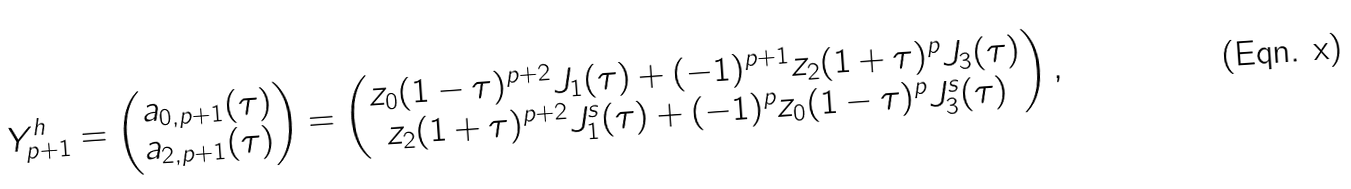Convert formula to latex. <formula><loc_0><loc_0><loc_500><loc_500>Y ^ { h } _ { p + 1 } = \begin{pmatrix} a _ { 0 , p + 1 } ( \tau ) \\ a _ { 2 , p + 1 } ( \tau ) \end{pmatrix} = \begin{pmatrix} z _ { 0 } ( 1 - \tau ) ^ { p + 2 } J _ { 1 } ( \tau ) + ( - 1 ) ^ { p + 1 } z _ { 2 } ( 1 + \tau ) ^ { p } J _ { 3 } ( \tau ) \\ z _ { 2 } ( 1 + \tau ) ^ { p + 2 } J ^ { s } _ { 1 } ( \tau ) + ( - 1 ) ^ { p } z _ { 0 } ( 1 - \tau ) ^ { p } J ^ { s } _ { 3 } ( \tau ) \end{pmatrix} ,</formula> 